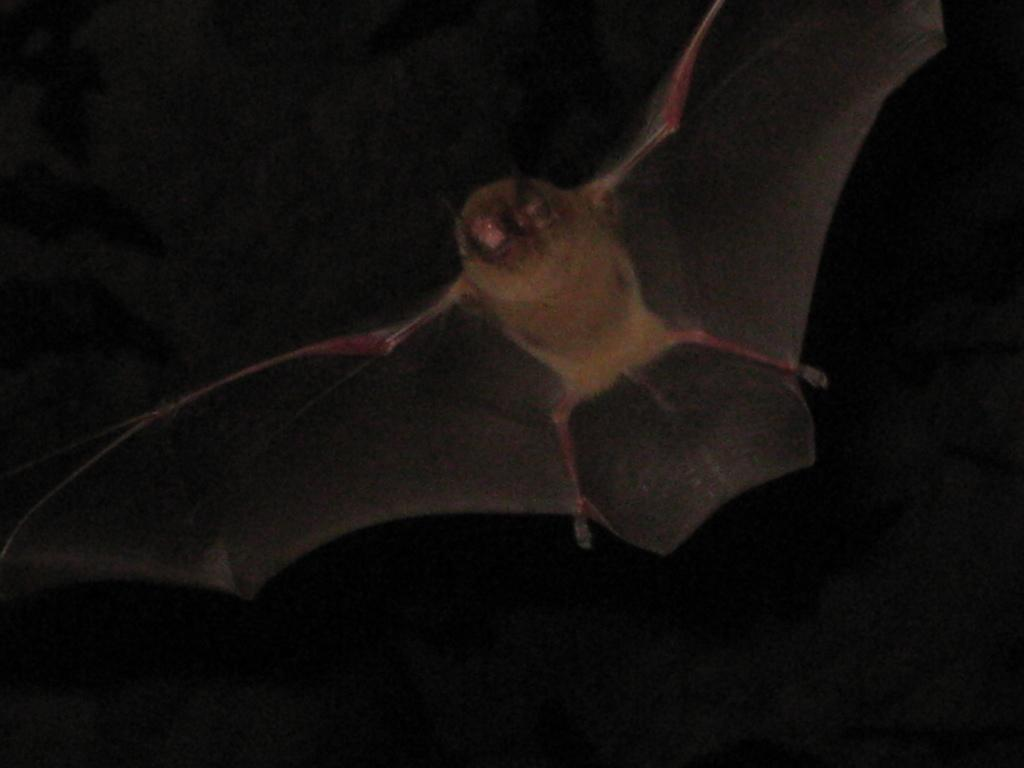What animal is present in the image? There is a bat in the image. What type of bird is sitting on the table during the meal in the image? There is no bird or meal present in the image; it features a bat. What type of wren can be seen in the image? There is no wren present in the image; it features a bat. 